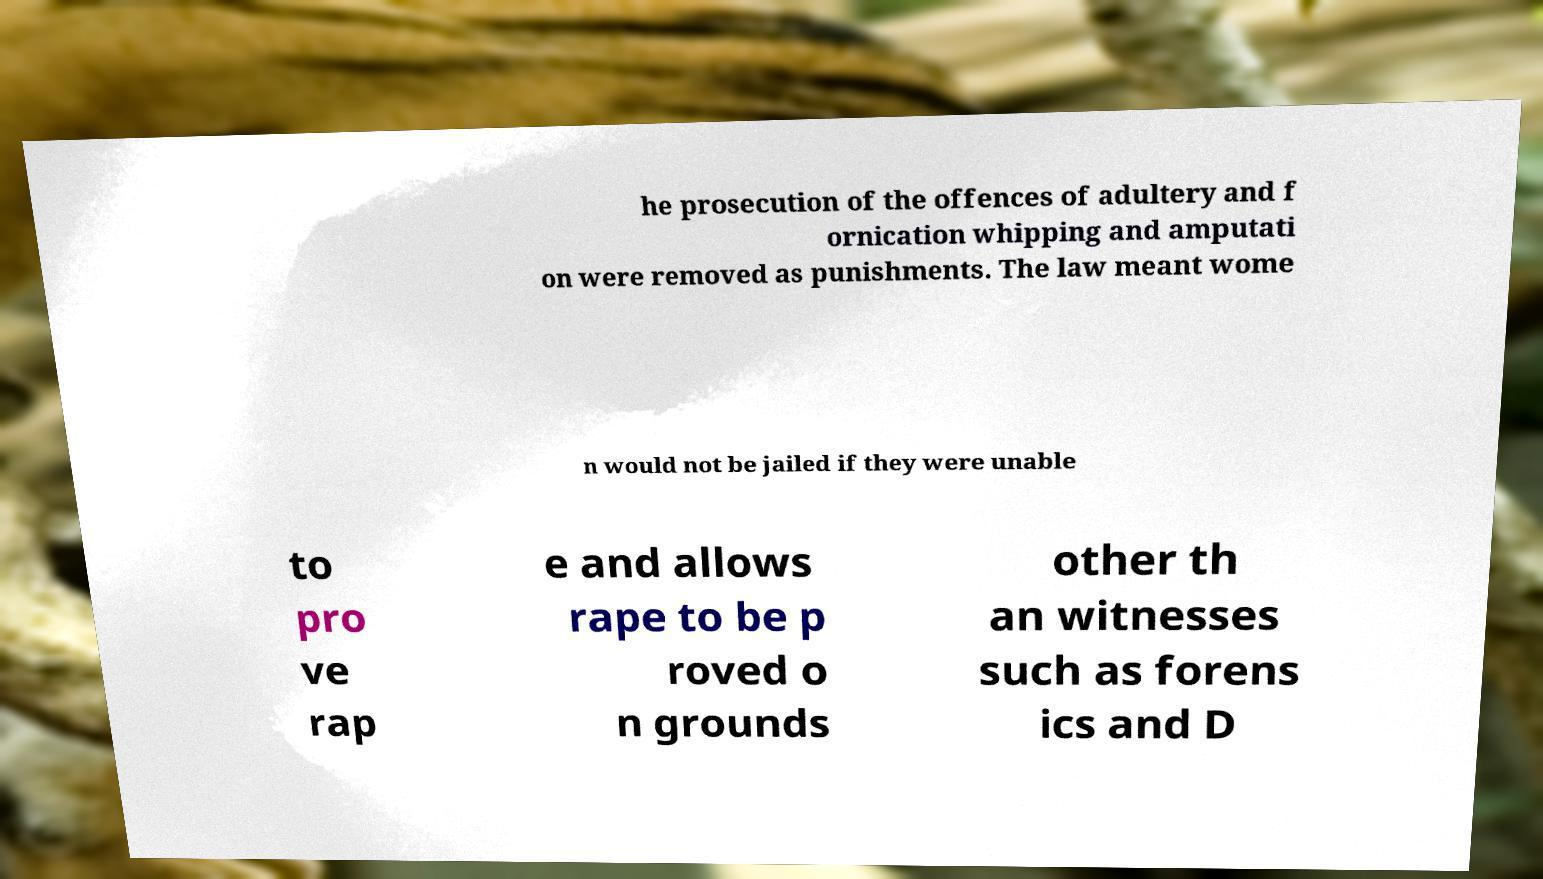There's text embedded in this image that I need extracted. Can you transcribe it verbatim? he prosecution of the offences of adultery and f ornication whipping and amputati on were removed as punishments. The law meant wome n would not be jailed if they were unable to pro ve rap e and allows rape to be p roved o n grounds other th an witnesses such as forens ics and D 